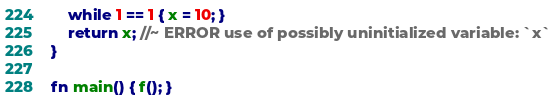Convert code to text. <code><loc_0><loc_0><loc_500><loc_500><_Rust_>    while 1 == 1 { x = 10; }
    return x; //~ ERROR use of possibly uninitialized variable: `x`
}

fn main() { f(); }
</code> 